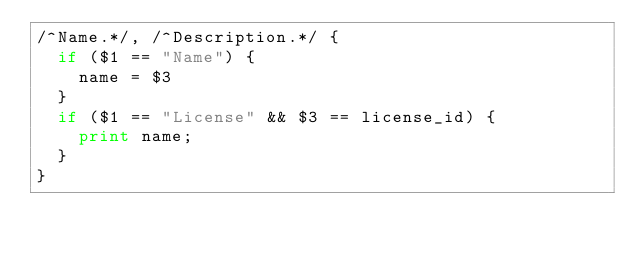Convert code to text. <code><loc_0><loc_0><loc_500><loc_500><_Awk_>/^Name.*/, /^Description.*/ {
	if ($1 == "Name") {
		name = $3
	}
	if ($1 == "License" && $3 == license_id) {
		print name;
	}
}
</code> 